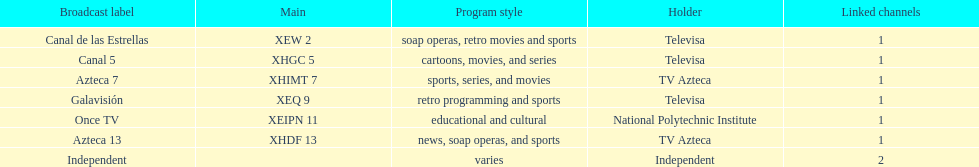Azteca 7 and azteca 13 are both owned by whom? TV Azteca. 